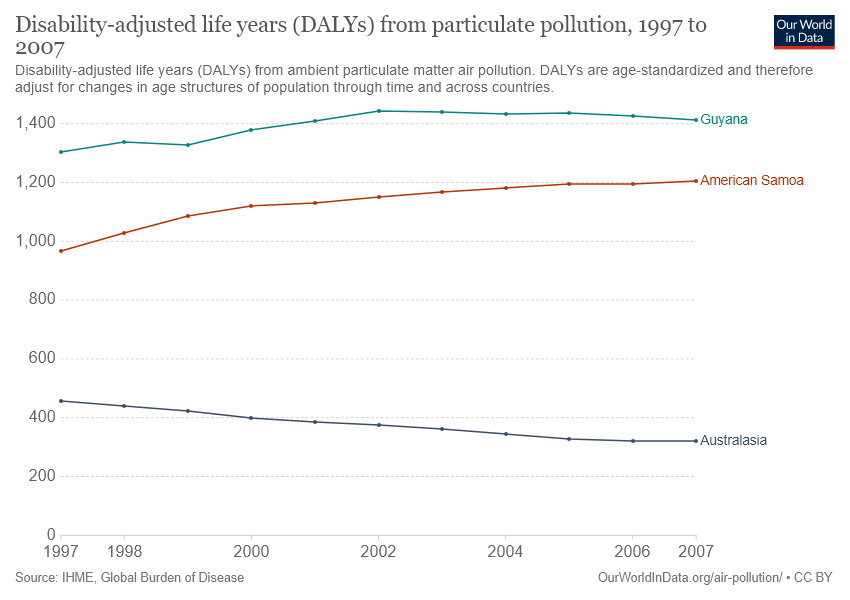Indicate a few pertinent items in this graphic. There are three color bars shown in the graph. The value that is shown between Guyana and American Samoa is 1200. 